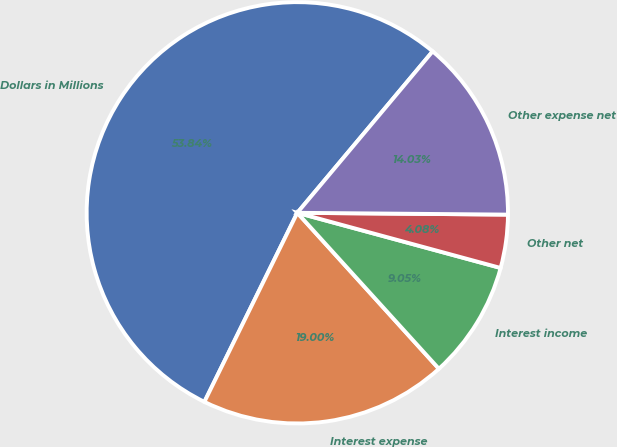Convert chart. <chart><loc_0><loc_0><loc_500><loc_500><pie_chart><fcel>Dollars in Millions<fcel>Interest expense<fcel>Interest income<fcel>Other net<fcel>Other expense net<nl><fcel>53.83%<fcel>19.0%<fcel>9.05%<fcel>4.08%<fcel>14.03%<nl></chart> 